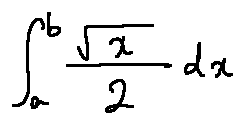Convert formula to latex. <formula><loc_0><loc_0><loc_500><loc_500>\int \lim i t s _ { a } ^ { b } \frac { \sqrt { x } } { 2 } d x</formula> 